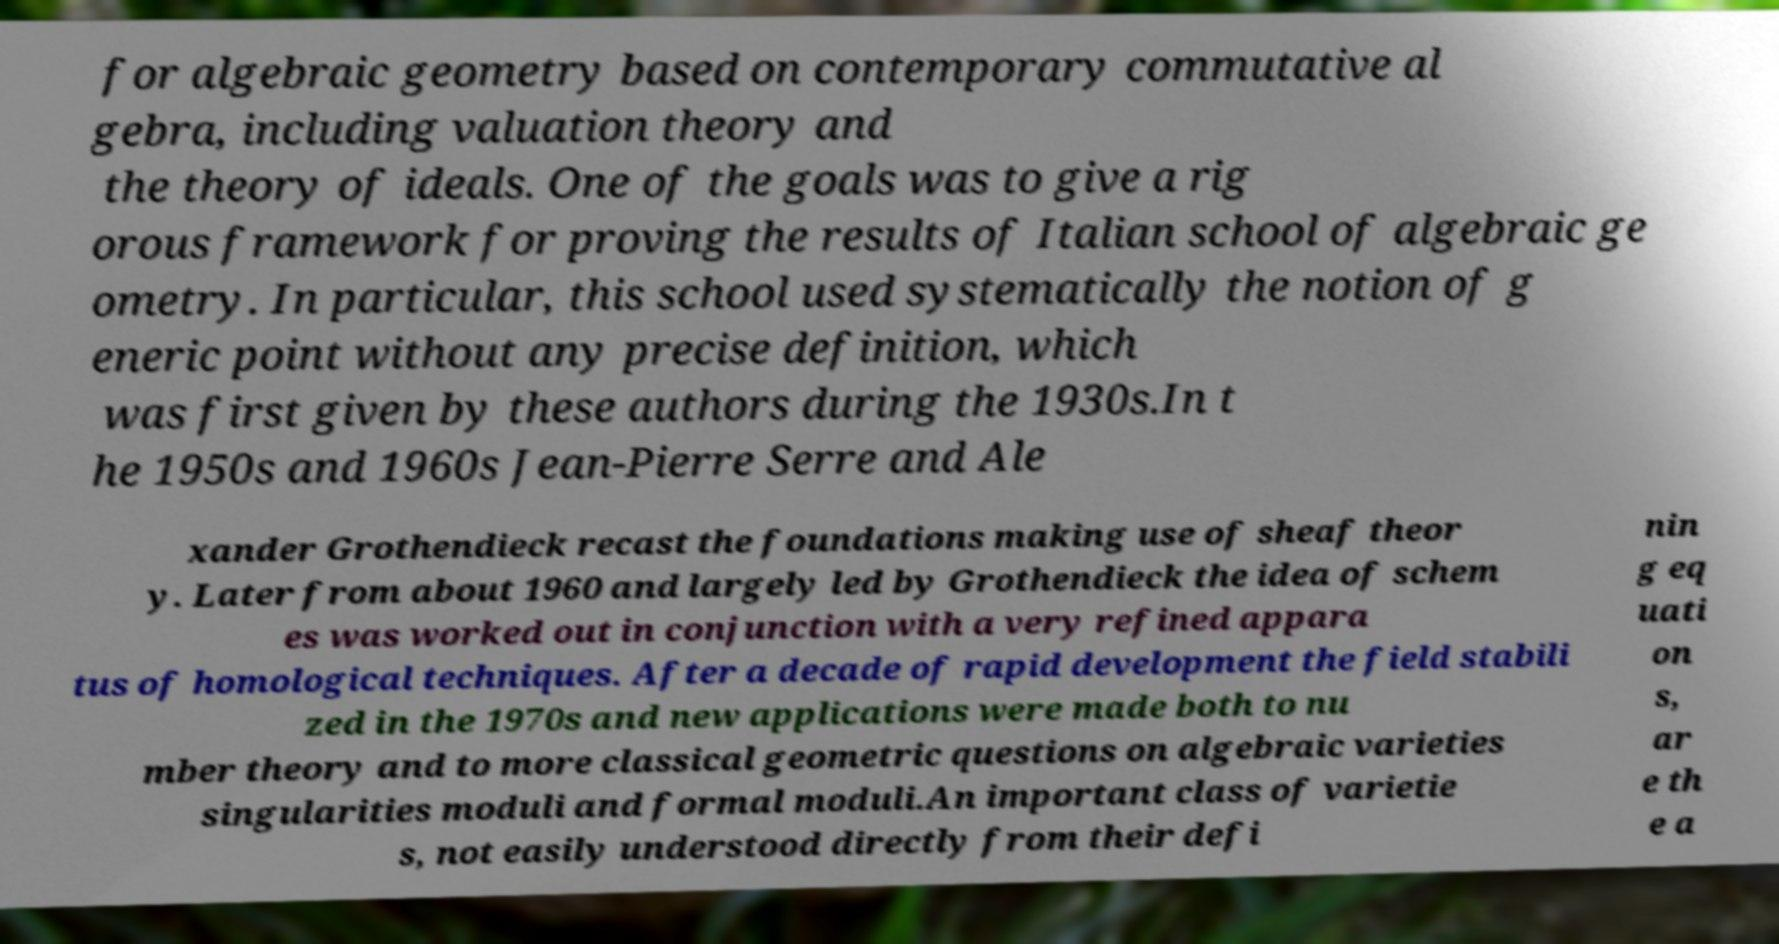Please read and relay the text visible in this image. What does it say? for algebraic geometry based on contemporary commutative al gebra, including valuation theory and the theory of ideals. One of the goals was to give a rig orous framework for proving the results of Italian school of algebraic ge ometry. In particular, this school used systematically the notion of g eneric point without any precise definition, which was first given by these authors during the 1930s.In t he 1950s and 1960s Jean-Pierre Serre and Ale xander Grothendieck recast the foundations making use of sheaf theor y. Later from about 1960 and largely led by Grothendieck the idea of schem es was worked out in conjunction with a very refined appara tus of homological techniques. After a decade of rapid development the field stabili zed in the 1970s and new applications were made both to nu mber theory and to more classical geometric questions on algebraic varieties singularities moduli and formal moduli.An important class of varietie s, not easily understood directly from their defi nin g eq uati on s, ar e th e a 